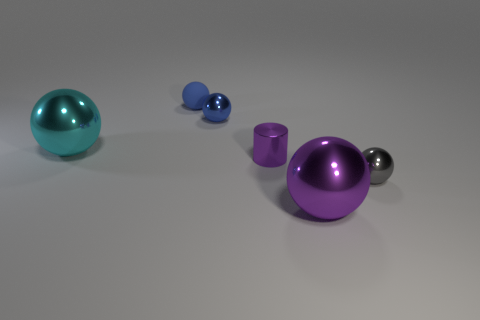Subtract all blue shiny spheres. How many spheres are left? 4 Add 1 big shiny spheres. How many objects exist? 7 Subtract all brown cylinders. How many blue balls are left? 2 Subtract 2 balls. How many balls are left? 3 Subtract all gray spheres. How many spheres are left? 4 Subtract all balls. How many objects are left? 1 Add 3 large gray matte things. How many large gray matte things exist? 3 Subtract 0 red balls. How many objects are left? 6 Subtract all brown spheres. Subtract all cyan cubes. How many spheres are left? 5 Subtract all metal cylinders. Subtract all large purple balls. How many objects are left? 4 